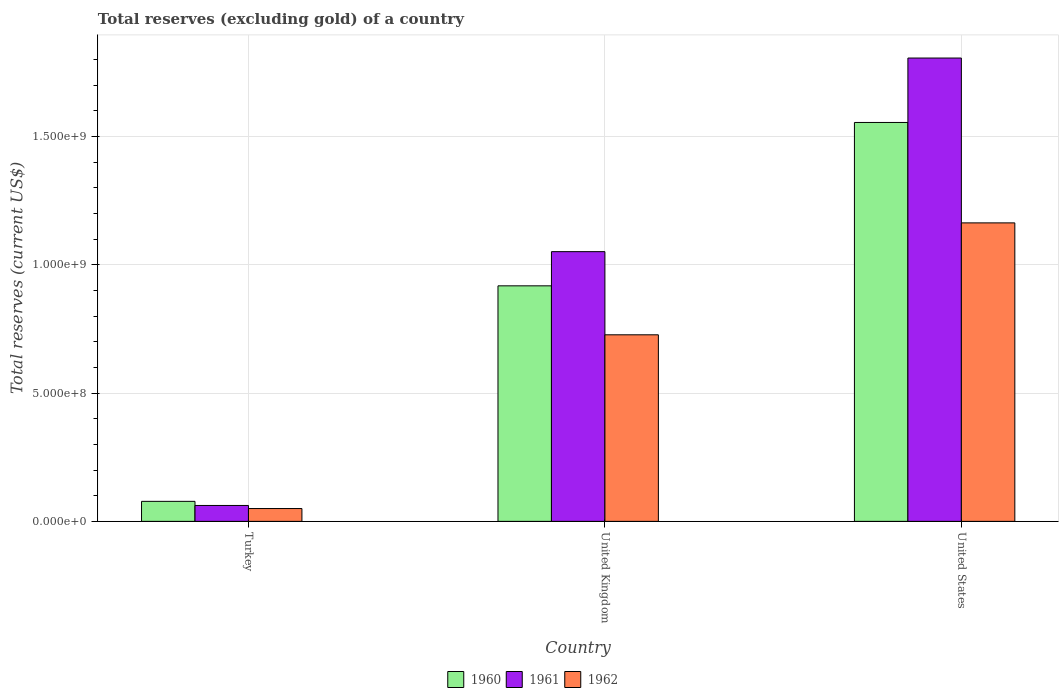How many different coloured bars are there?
Provide a succinct answer. 3. Are the number of bars per tick equal to the number of legend labels?
Your answer should be compact. Yes. How many bars are there on the 2nd tick from the right?
Your answer should be very brief. 3. In how many cases, is the number of bars for a given country not equal to the number of legend labels?
Give a very brief answer. 0. What is the total reserves (excluding gold) in 1961 in Turkey?
Provide a succinct answer. 6.20e+07. Across all countries, what is the maximum total reserves (excluding gold) in 1960?
Provide a succinct answer. 1.55e+09. In which country was the total reserves (excluding gold) in 1960 minimum?
Ensure brevity in your answer.  Turkey. What is the total total reserves (excluding gold) in 1960 in the graph?
Provide a succinct answer. 2.55e+09. What is the difference between the total reserves (excluding gold) in 1961 in Turkey and that in United Kingdom?
Your answer should be compact. -9.89e+08. What is the difference between the total reserves (excluding gold) in 1962 in United Kingdom and the total reserves (excluding gold) in 1960 in United States?
Keep it short and to the point. -8.28e+08. What is the average total reserves (excluding gold) in 1962 per country?
Offer a terse response. 6.47e+08. What is the difference between the total reserves (excluding gold) of/in 1962 and total reserves (excluding gold) of/in 1960 in United States?
Provide a short and direct response. -3.91e+08. What is the ratio of the total reserves (excluding gold) in 1960 in Turkey to that in United Kingdom?
Keep it short and to the point. 0.08. Is the total reserves (excluding gold) in 1962 in Turkey less than that in United States?
Your response must be concise. Yes. What is the difference between the highest and the second highest total reserves (excluding gold) in 1962?
Ensure brevity in your answer.  6.77e+08. What is the difference between the highest and the lowest total reserves (excluding gold) in 1960?
Keep it short and to the point. 1.48e+09. Is the sum of the total reserves (excluding gold) in 1962 in Turkey and United Kingdom greater than the maximum total reserves (excluding gold) in 1961 across all countries?
Make the answer very short. No. What does the 3rd bar from the left in Turkey represents?
Give a very brief answer. 1962. How many bars are there?
Your response must be concise. 9. Are the values on the major ticks of Y-axis written in scientific E-notation?
Provide a short and direct response. Yes. Does the graph contain any zero values?
Provide a short and direct response. No. How many legend labels are there?
Make the answer very short. 3. How are the legend labels stacked?
Provide a succinct answer. Horizontal. What is the title of the graph?
Your response must be concise. Total reserves (excluding gold) of a country. What is the label or title of the X-axis?
Your answer should be very brief. Country. What is the label or title of the Y-axis?
Your answer should be very brief. Total reserves (current US$). What is the Total reserves (current US$) in 1960 in Turkey?
Your answer should be compact. 7.80e+07. What is the Total reserves (current US$) in 1961 in Turkey?
Give a very brief answer. 6.20e+07. What is the Total reserves (current US$) of 1962 in Turkey?
Offer a very short reply. 5.00e+07. What is the Total reserves (current US$) of 1960 in United Kingdom?
Offer a terse response. 9.18e+08. What is the Total reserves (current US$) of 1961 in United Kingdom?
Provide a short and direct response. 1.05e+09. What is the Total reserves (current US$) in 1962 in United Kingdom?
Your response must be concise. 7.27e+08. What is the Total reserves (current US$) in 1960 in United States?
Your response must be concise. 1.55e+09. What is the Total reserves (current US$) of 1961 in United States?
Your answer should be very brief. 1.81e+09. What is the Total reserves (current US$) of 1962 in United States?
Give a very brief answer. 1.16e+09. Across all countries, what is the maximum Total reserves (current US$) in 1960?
Ensure brevity in your answer.  1.55e+09. Across all countries, what is the maximum Total reserves (current US$) of 1961?
Provide a short and direct response. 1.81e+09. Across all countries, what is the maximum Total reserves (current US$) of 1962?
Make the answer very short. 1.16e+09. Across all countries, what is the minimum Total reserves (current US$) of 1960?
Your answer should be compact. 7.80e+07. Across all countries, what is the minimum Total reserves (current US$) of 1961?
Your answer should be compact. 6.20e+07. Across all countries, what is the minimum Total reserves (current US$) of 1962?
Give a very brief answer. 5.00e+07. What is the total Total reserves (current US$) of 1960 in the graph?
Give a very brief answer. 2.55e+09. What is the total Total reserves (current US$) in 1961 in the graph?
Provide a short and direct response. 2.92e+09. What is the total Total reserves (current US$) of 1962 in the graph?
Provide a succinct answer. 1.94e+09. What is the difference between the Total reserves (current US$) of 1960 in Turkey and that in United Kingdom?
Your answer should be compact. -8.40e+08. What is the difference between the Total reserves (current US$) of 1961 in Turkey and that in United Kingdom?
Your response must be concise. -9.89e+08. What is the difference between the Total reserves (current US$) of 1962 in Turkey and that in United Kingdom?
Your response must be concise. -6.77e+08. What is the difference between the Total reserves (current US$) of 1960 in Turkey and that in United States?
Your answer should be very brief. -1.48e+09. What is the difference between the Total reserves (current US$) of 1961 in Turkey and that in United States?
Give a very brief answer. -1.74e+09. What is the difference between the Total reserves (current US$) of 1962 in Turkey and that in United States?
Your answer should be compact. -1.11e+09. What is the difference between the Total reserves (current US$) in 1960 in United Kingdom and that in United States?
Offer a terse response. -6.37e+08. What is the difference between the Total reserves (current US$) of 1961 in United Kingdom and that in United States?
Offer a very short reply. -7.55e+08. What is the difference between the Total reserves (current US$) in 1962 in United Kingdom and that in United States?
Keep it short and to the point. -4.36e+08. What is the difference between the Total reserves (current US$) in 1960 in Turkey and the Total reserves (current US$) in 1961 in United Kingdom?
Give a very brief answer. -9.73e+08. What is the difference between the Total reserves (current US$) in 1960 in Turkey and the Total reserves (current US$) in 1962 in United Kingdom?
Provide a succinct answer. -6.49e+08. What is the difference between the Total reserves (current US$) in 1961 in Turkey and the Total reserves (current US$) in 1962 in United Kingdom?
Your response must be concise. -6.65e+08. What is the difference between the Total reserves (current US$) in 1960 in Turkey and the Total reserves (current US$) in 1961 in United States?
Keep it short and to the point. -1.73e+09. What is the difference between the Total reserves (current US$) in 1960 in Turkey and the Total reserves (current US$) in 1962 in United States?
Your answer should be very brief. -1.09e+09. What is the difference between the Total reserves (current US$) of 1961 in Turkey and the Total reserves (current US$) of 1962 in United States?
Ensure brevity in your answer.  -1.10e+09. What is the difference between the Total reserves (current US$) of 1960 in United Kingdom and the Total reserves (current US$) of 1961 in United States?
Give a very brief answer. -8.88e+08. What is the difference between the Total reserves (current US$) of 1960 in United Kingdom and the Total reserves (current US$) of 1962 in United States?
Your response must be concise. -2.45e+08. What is the difference between the Total reserves (current US$) in 1961 in United Kingdom and the Total reserves (current US$) in 1962 in United States?
Offer a very short reply. -1.12e+08. What is the average Total reserves (current US$) in 1960 per country?
Your answer should be very brief. 8.50e+08. What is the average Total reserves (current US$) in 1961 per country?
Provide a short and direct response. 9.73e+08. What is the average Total reserves (current US$) of 1962 per country?
Ensure brevity in your answer.  6.47e+08. What is the difference between the Total reserves (current US$) of 1960 and Total reserves (current US$) of 1961 in Turkey?
Keep it short and to the point. 1.60e+07. What is the difference between the Total reserves (current US$) in 1960 and Total reserves (current US$) in 1962 in Turkey?
Provide a succinct answer. 2.80e+07. What is the difference between the Total reserves (current US$) of 1960 and Total reserves (current US$) of 1961 in United Kingdom?
Your answer should be very brief. -1.33e+08. What is the difference between the Total reserves (current US$) in 1960 and Total reserves (current US$) in 1962 in United Kingdom?
Offer a terse response. 1.91e+08. What is the difference between the Total reserves (current US$) of 1961 and Total reserves (current US$) of 1962 in United Kingdom?
Provide a short and direct response. 3.24e+08. What is the difference between the Total reserves (current US$) in 1960 and Total reserves (current US$) in 1961 in United States?
Your answer should be very brief. -2.51e+08. What is the difference between the Total reserves (current US$) of 1960 and Total reserves (current US$) of 1962 in United States?
Keep it short and to the point. 3.91e+08. What is the difference between the Total reserves (current US$) in 1961 and Total reserves (current US$) in 1962 in United States?
Ensure brevity in your answer.  6.42e+08. What is the ratio of the Total reserves (current US$) of 1960 in Turkey to that in United Kingdom?
Your answer should be compact. 0.09. What is the ratio of the Total reserves (current US$) in 1961 in Turkey to that in United Kingdom?
Make the answer very short. 0.06. What is the ratio of the Total reserves (current US$) of 1962 in Turkey to that in United Kingdom?
Provide a succinct answer. 0.07. What is the ratio of the Total reserves (current US$) in 1960 in Turkey to that in United States?
Your answer should be very brief. 0.05. What is the ratio of the Total reserves (current US$) of 1961 in Turkey to that in United States?
Give a very brief answer. 0.03. What is the ratio of the Total reserves (current US$) of 1962 in Turkey to that in United States?
Offer a very short reply. 0.04. What is the ratio of the Total reserves (current US$) in 1960 in United Kingdom to that in United States?
Ensure brevity in your answer.  0.59. What is the ratio of the Total reserves (current US$) of 1961 in United Kingdom to that in United States?
Your answer should be compact. 0.58. What is the difference between the highest and the second highest Total reserves (current US$) in 1960?
Provide a short and direct response. 6.37e+08. What is the difference between the highest and the second highest Total reserves (current US$) of 1961?
Keep it short and to the point. 7.55e+08. What is the difference between the highest and the second highest Total reserves (current US$) in 1962?
Give a very brief answer. 4.36e+08. What is the difference between the highest and the lowest Total reserves (current US$) of 1960?
Ensure brevity in your answer.  1.48e+09. What is the difference between the highest and the lowest Total reserves (current US$) in 1961?
Keep it short and to the point. 1.74e+09. What is the difference between the highest and the lowest Total reserves (current US$) in 1962?
Provide a succinct answer. 1.11e+09. 